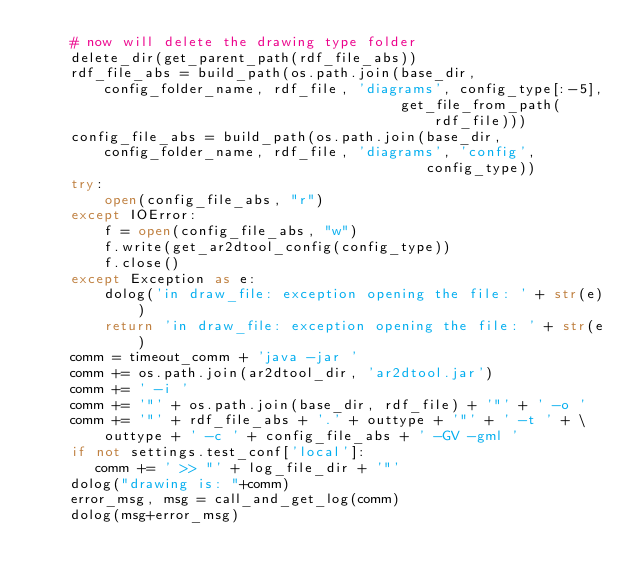Convert code to text. <code><loc_0><loc_0><loc_500><loc_500><_Python_>    # now will delete the drawing type folder
    delete_dir(get_parent_path(rdf_file_abs))
    rdf_file_abs = build_path(os.path.join(base_dir, config_folder_name, rdf_file, 'diagrams', config_type[:-5],
                                           get_file_from_path(rdf_file)))
    config_file_abs = build_path(os.path.join(base_dir, config_folder_name, rdf_file, 'diagrams', 'config',
                                              config_type))
    try:
        open(config_file_abs, "r")
    except IOError:
        f = open(config_file_abs, "w")
        f.write(get_ar2dtool_config(config_type))
        f.close()
    except Exception as e:
        dolog('in draw_file: exception opening the file: ' + str(e))
        return 'in draw_file: exception opening the file: ' + str(e)
    comm = timeout_comm + 'java -jar '
    comm += os.path.join(ar2dtool_dir, 'ar2dtool.jar')
    comm += ' -i '
    comm += '"' + os.path.join(base_dir, rdf_file) + '"' + ' -o '
    comm += '"' + rdf_file_abs + '.' + outtype + '"' + ' -t ' + \
        outtype + ' -c ' + config_file_abs + ' -GV -gml '
    if not settings.test_conf['local']:
       comm += ' >> "' + log_file_dir + '"'
    dolog("drawing is: "+comm)
    error_msg, msg = call_and_get_log(comm)
    dolog(msg+error_msg)</code> 